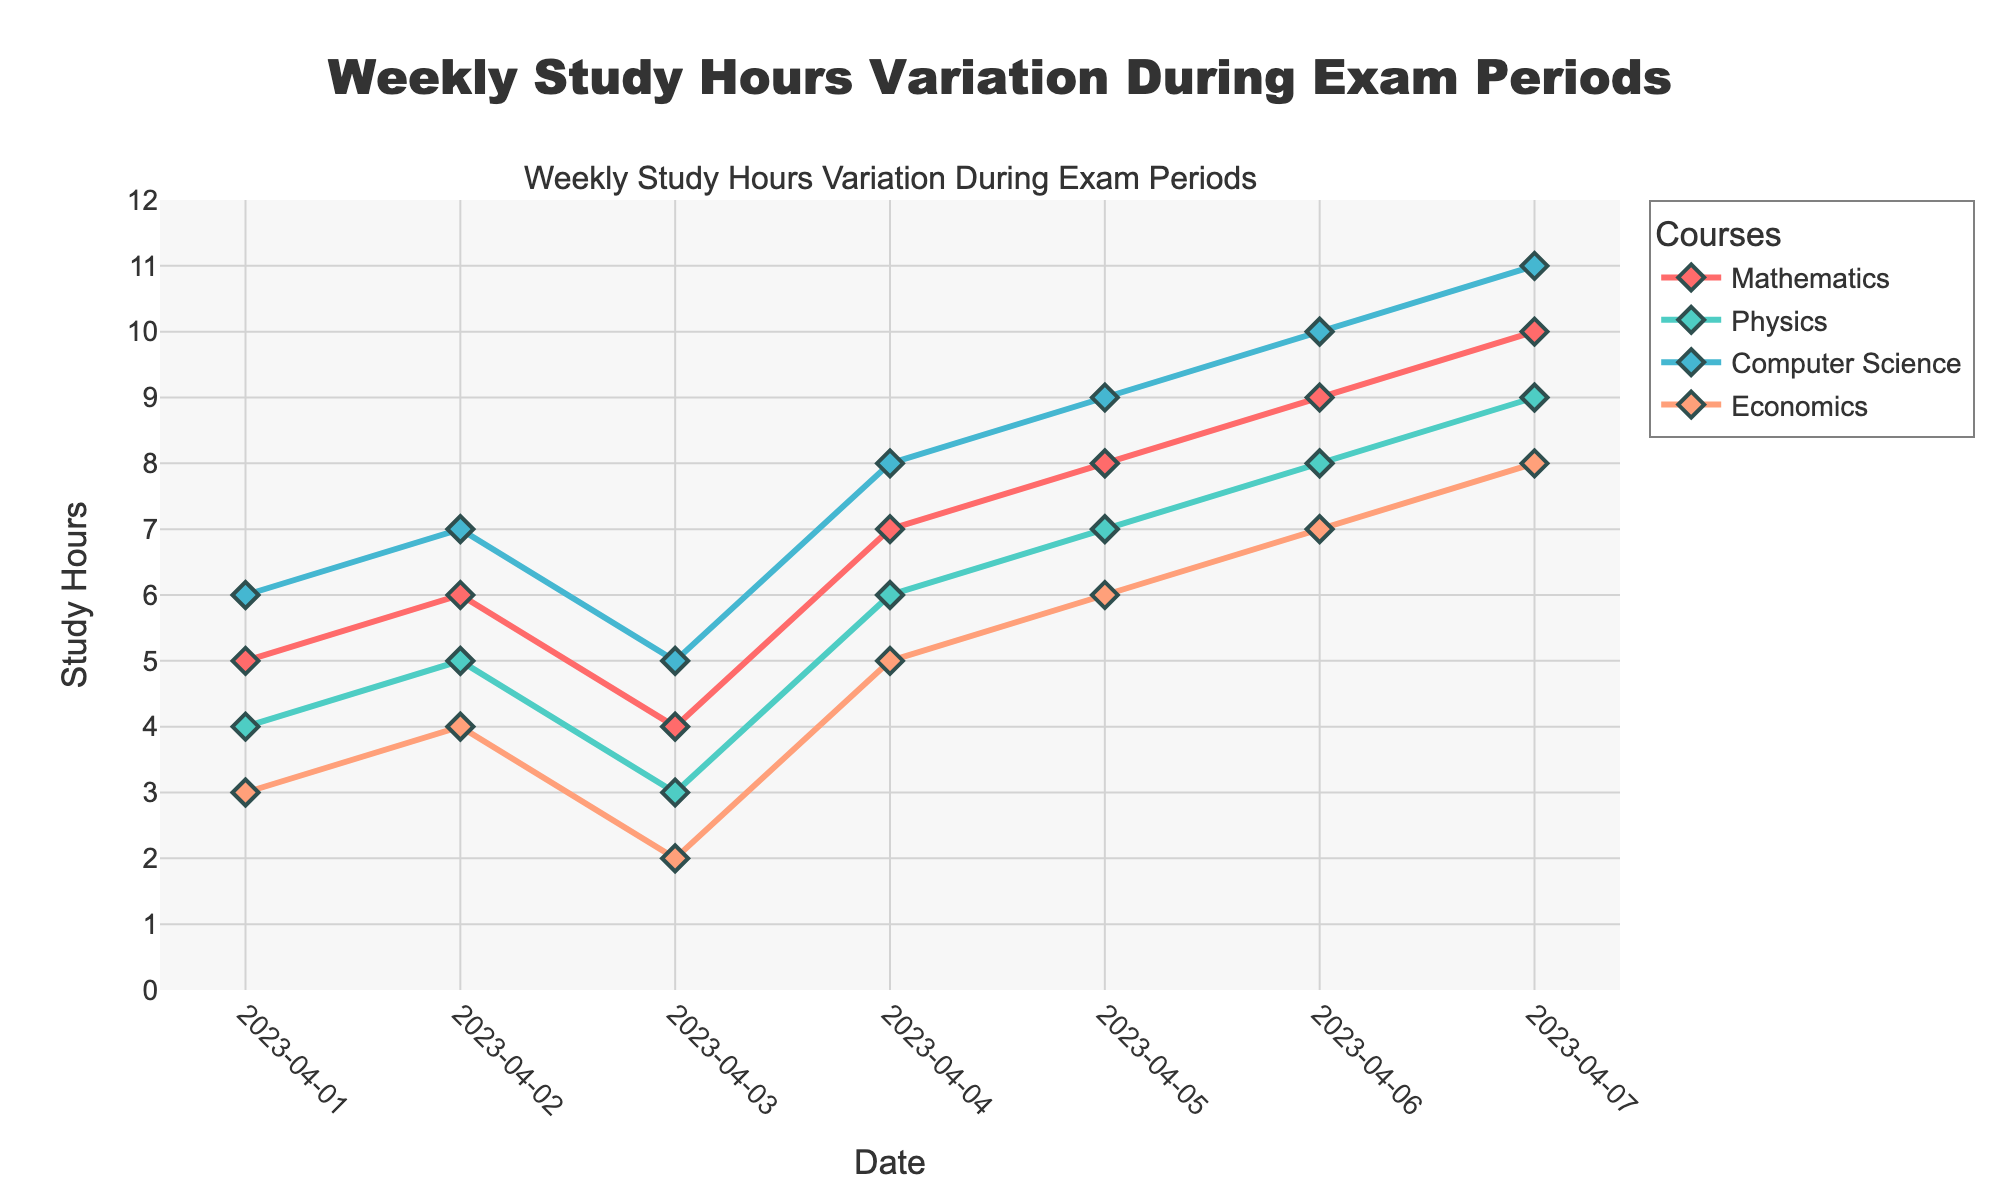What's the title of the plot? The title is usually prominently displayed at the top of the figure. In this case, the plot title is "Weekly Study Hours Variation During Exam Periods".
Answer: Weekly Study Hours Variation During Exam Periods What does the x-axis represent? The x-axis should have labels that indicate the type of data it represents. Here, the x-axis shows different dates.
Answer: Date What does the y-axis represent? The y-axis labels indicate what is being measured. In this plot, it represents the Study Hours.
Answer: Study Hours How many courses are being compared in the plot? The legend or different colored lines in the plot can help identify the number of courses. Here, there are four courses: Mathematics, Physics, Computer Science, and Economics.
Answer: 4 What color represents the course 'Computer Science'? By looking at the legend on the plot, we can see that blue is used for 'Computer Science'.
Answer: Blue On which date did 'Mathematics' have the highest number of study hours? By observing the plot, we can see that for Mathematics, April 7 had the highest value at 10 study hours.
Answer: April 7 What is the difference in study hours between 'Mathematics' and 'Economics' on April 4? By looking at the values on April 4 for both courses, Mathematics had 7 study hours and Economics had 5 study hours. The difference is 2 hours.
Answer: 2 Calculate the average study hours for 'Physics' from April 1 to April 7. Sum the study hours for Physics from April 1 to April 7 (4 + 5 + 3 + 6 + 7 + 8 + 9 = 42) and divide by the number of days (7), resulting in an average of 6 hours.
Answer: 6 Which course showed the most consistent study pattern over the week? Consistency can be identified by observing the least variation in study hours over the week. 'Computer Science' shows a steady increase in study hours from 6 to 11.
Answer: Computer Science Compare the trend of 'Physics' and 'Economics' over the week. Which course had a higher increase in study hours? Both trends must be observed from the starting point to the end point. 'Physics' started at 4 and ended at 9, increasing by 5 hours. 'Economics' started at 3 and ended at 8, also increasing by 5 hours. Both had the same increase.
Answer: Both had the same increase 